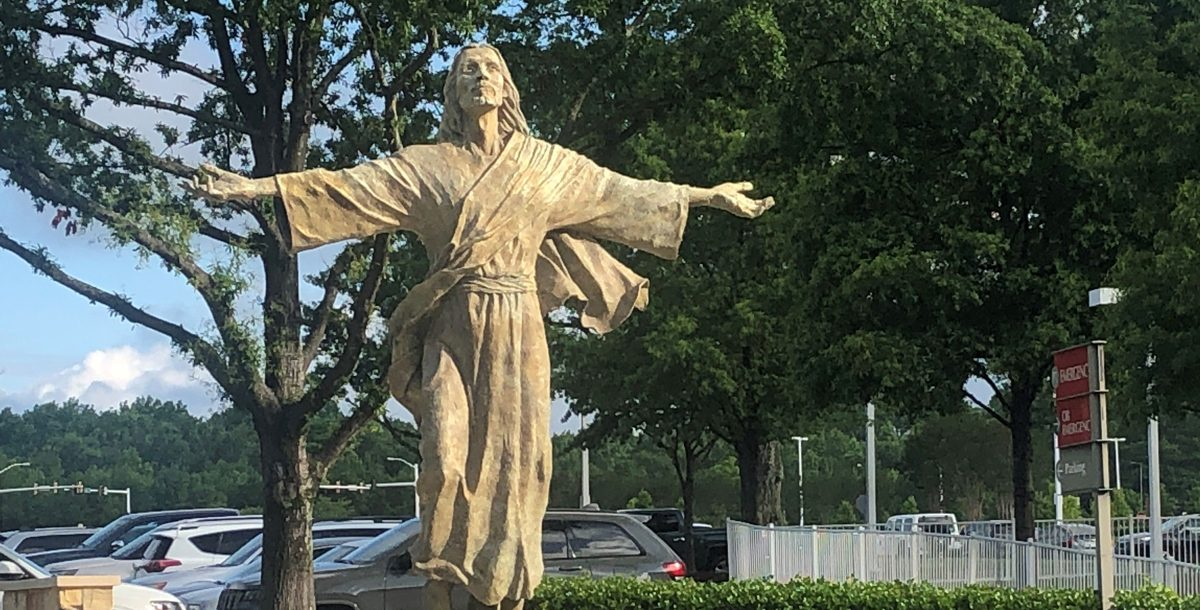How does the lighting and time of day affect the perception of this statue? The warm lighting, possibly indicating a late afternoon setting, casts soft shadows and highlights on the statue, enhancing its ethereal and serene demeanor. This time of day might make the statue appear more inviting and impactful, evoking feelings of peace and calm as one might experience during a reflective evening walk. Does the statue have any specific artistic features that contribute to its impact? Yes, the textured surface of the statue highlights its detailed drapery and facial expressions, allowing it to convey emotions vividly. The dynamism suggested by its pose, with arms outstretched, adds an element of motion, making the statue appear alive and interactive, further engaging onlookers. 